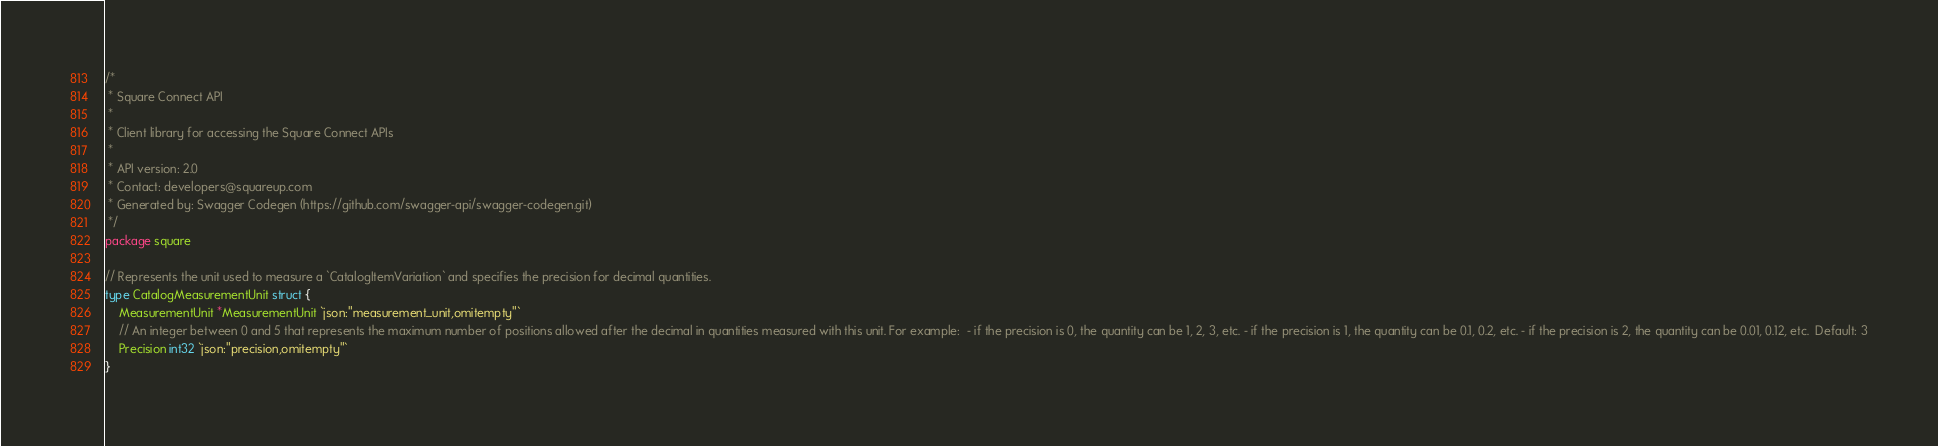<code> <loc_0><loc_0><loc_500><loc_500><_Go_>/*
 * Square Connect API
 *
 * Client library for accessing the Square Connect APIs
 *
 * API version: 2.0
 * Contact: developers@squareup.com
 * Generated by: Swagger Codegen (https://github.com/swagger-api/swagger-codegen.git)
 */
package square

// Represents the unit used to measure a `CatalogItemVariation` and specifies the precision for decimal quantities.
type CatalogMeasurementUnit struct {
	MeasurementUnit *MeasurementUnit `json:"measurement_unit,omitempty"`
	// An integer between 0 and 5 that represents the maximum number of positions allowed after the decimal in quantities measured with this unit. For example:  - if the precision is 0, the quantity can be 1, 2, 3, etc. - if the precision is 1, the quantity can be 0.1, 0.2, etc. - if the precision is 2, the quantity can be 0.01, 0.12, etc.  Default: 3
	Precision int32 `json:"precision,omitempty"`
}
</code> 